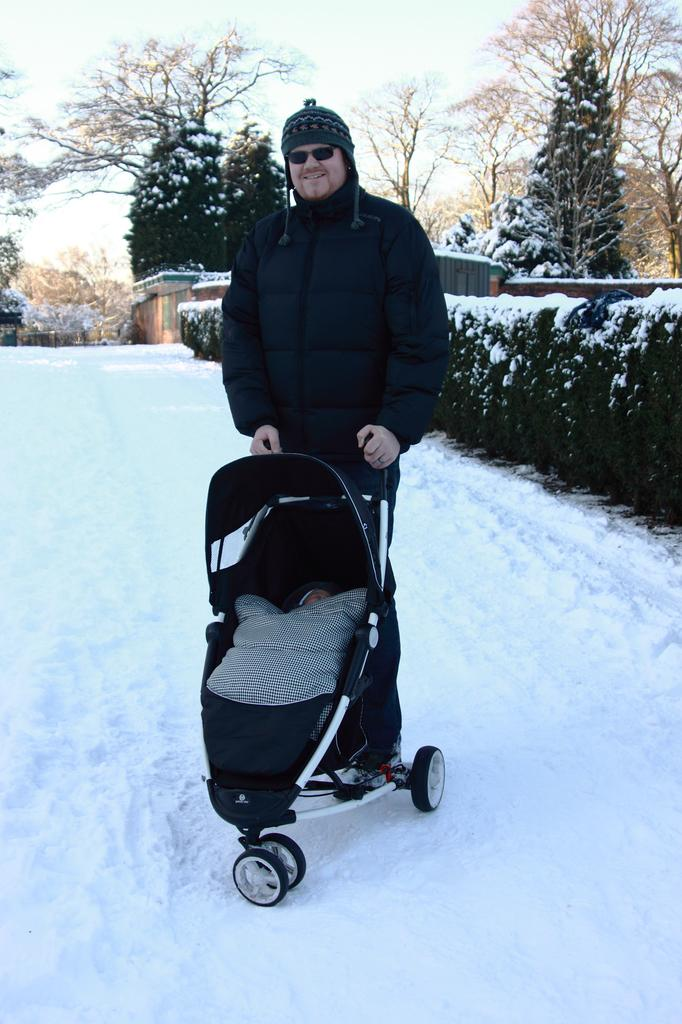Who is the main subject in the image? There is a man in the middle of the image. What is the man holding in the image? The man is holding a baby cart. What is the weather like in the image? There is snow visible in the image, indicating a cold and wintry scene. What type of vegetation can be seen on the right side of the image? There are trees on the right side of the image. What is visible at the top of the image? The sky is visible at the top of the image. What type of worm can be seen crawling on the man's shoulder in the image? There are no worms present in the image; the man is holding a baby cart and there is snow visible in the scene. 